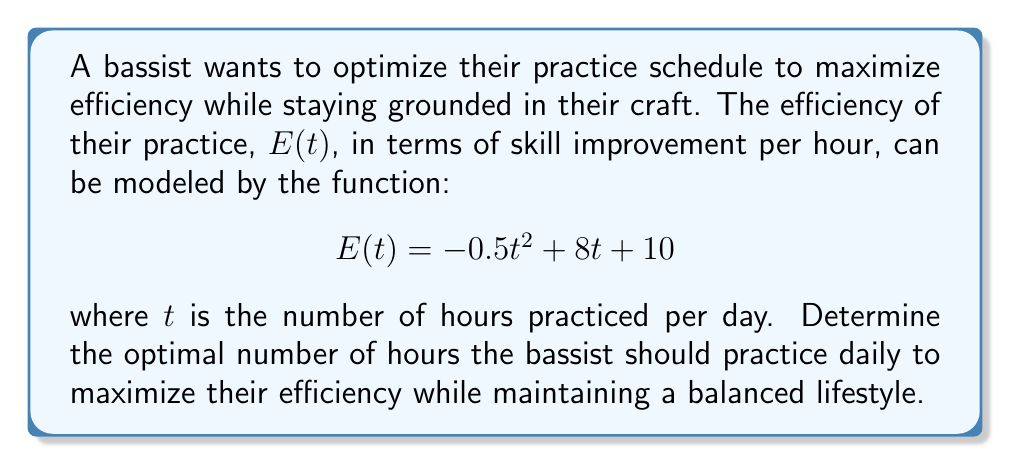What is the answer to this math problem? To find the maximum efficiency point, we need to follow these steps:

1) The efficiency function E(t) is a quadratic function, and its graph is a parabola that opens downward (because the coefficient of $t^2$ is negative).

2) The maximum point of a parabola occurs at the vertex. For a quadratic function in the form $f(t) = at^2 + bt + c$, the t-coordinate of the vertex is given by $t = -\frac{b}{2a}$.

3) In our case, $a = -0.5$, $b = 8$, and $c = 10$. Let's substitute these values:

   $$t = -\frac{8}{2(-0.5)} = -\frac{8}{-1} = 8$$

4) This means the efficiency is maximized when the bassist practices for 8 hours per day.

5) To find the maximum efficiency value, we substitute t = 8 into the original function:

   $$E(8) = -0.5(8)^2 + 8(8) + 10$$
   $$= -0.5(64) + 64 + 10$$
   $$= -32 + 64 + 10$$
   $$= 42$$

6) Therefore, the maximum efficiency is 42 units of skill improvement per hour, achieved at 8 hours of practice per day.

7) However, practicing for 8 hours daily might not align with maintaining a balanced lifestyle. A more grounded approach could be to practice for a duration closer to half of this optimal time, around 4 hours per day. This would still provide significant efficiency while allowing time for other activities and preventing burnout.
Answer: The optimal practice duration for maximum efficiency is 8 hours per day, yielding an efficiency of 42 units. However, for a more balanced approach, a practice schedule of about 4 hours per day is recommended. 